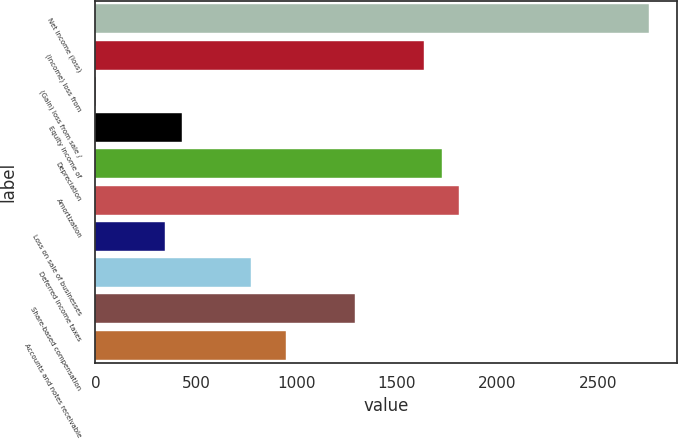<chart> <loc_0><loc_0><loc_500><loc_500><bar_chart><fcel>Net income (loss)<fcel>(Income) loss from<fcel>(Gain) loss from sale /<fcel>Equity income of<fcel>Depreciation<fcel>Amortization<fcel>Loss on sale of businesses<fcel>Deferred income taxes<fcel>Share-based compensation<fcel>Accounts and notes receivable<nl><fcel>2755.16<fcel>1636.12<fcel>0.6<fcel>431<fcel>1722.2<fcel>1808.28<fcel>344.92<fcel>775.32<fcel>1291.8<fcel>947.48<nl></chart> 